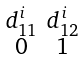<formula> <loc_0><loc_0><loc_500><loc_500>\begin{smallmatrix} d ^ { i } _ { 1 1 } & d ^ { i } _ { 1 2 } \\ 0 & 1 \end{smallmatrix}</formula> 